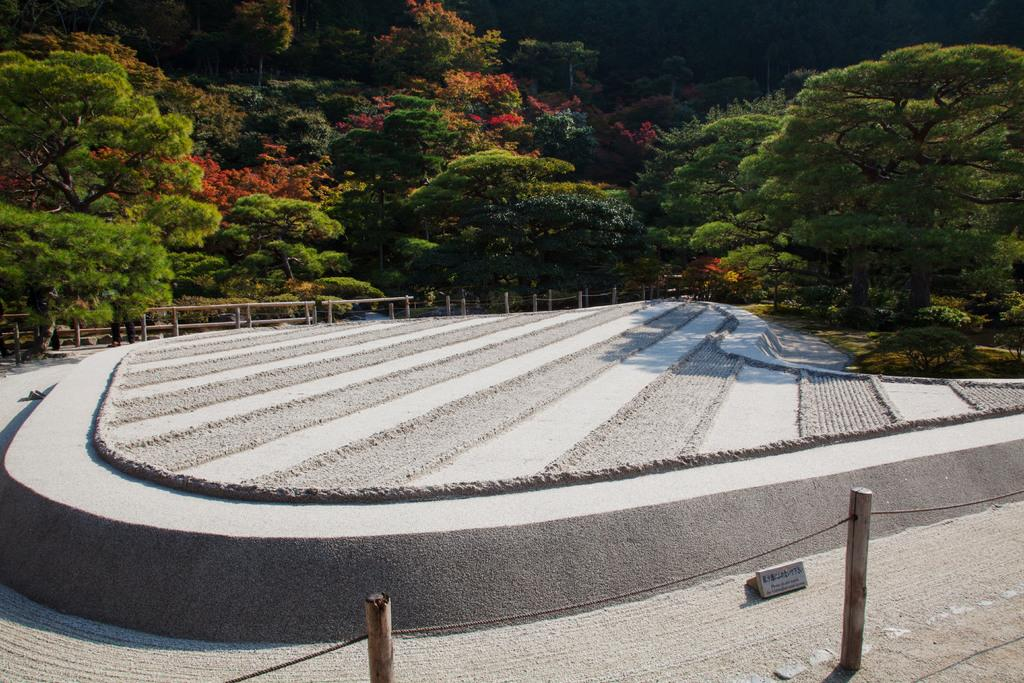What is at the bottom of the image? There is a floor at the bottom of the image. What can be seen in the distance in the image? There are trees in the background of the image. What date is marked on the calendar in the image? There is no calendar present in the image. What type of animal can be seen interacting with the trees in the image? There are no animals present in the image, including zebras. 